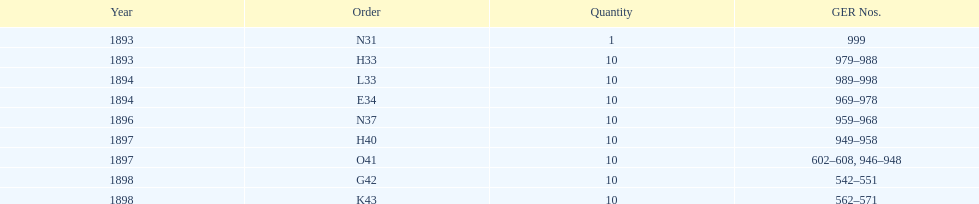What is the cumulative quantity of locomotives created during this duration? 81. 